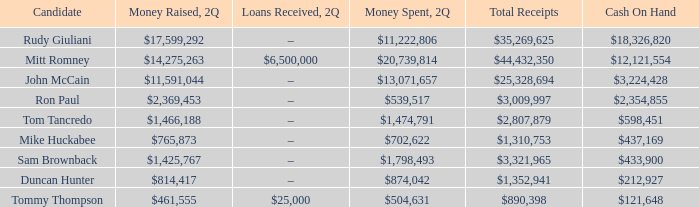Can you parse all the data within this table? {'header': ['Candidate', 'Money Raised, 2Q', 'Loans Received, 2Q', 'Money Spent, 2Q', 'Total Receipts', 'Cash On Hand'], 'rows': [['Rudy Giuliani', '$17,599,292', '–', '$11,222,806', '$35,269,625', '$18,326,820'], ['Mitt Romney', '$14,275,263', '$6,500,000', '$20,739,814', '$44,432,350', '$12,121,554'], ['John McCain', '$11,591,044', '–', '$13,071,657', '$25,328,694', '$3,224,428'], ['Ron Paul', '$2,369,453', '–', '$539,517', '$3,009,997', '$2,354,855'], ['Tom Tancredo', '$1,466,188', '–', '$1,474,791', '$2,807,879', '$598,451'], ['Mike Huckabee', '$765,873', '–', '$702,622', '$1,310,753', '$437,169'], ['Sam Brownback', '$1,425,767', '–', '$1,798,493', '$3,321,965', '$433,900'], ['Duncan Hunter', '$814,417', '–', '$874,042', '$1,352,941', '$212,927'], ['Tommy Thompson', '$461,555', '$25,000', '$504,631', '$890,398', '$121,648']]} Name the money raised when 2Q has money spent and 2Q is $874,042 $814,417. 